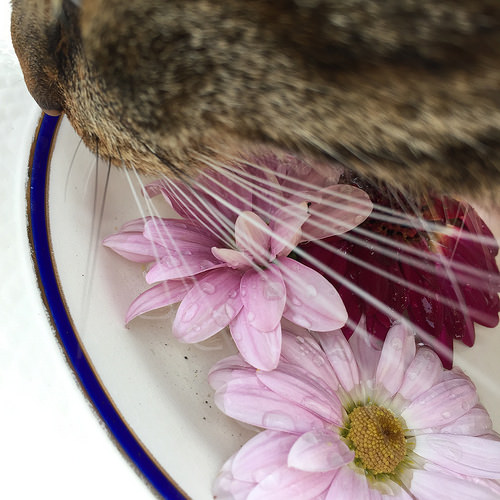<image>
Is there a bunny on the flower? No. The bunny is not positioned on the flower. They may be near each other, but the bunny is not supported by or resting on top of the flower. 